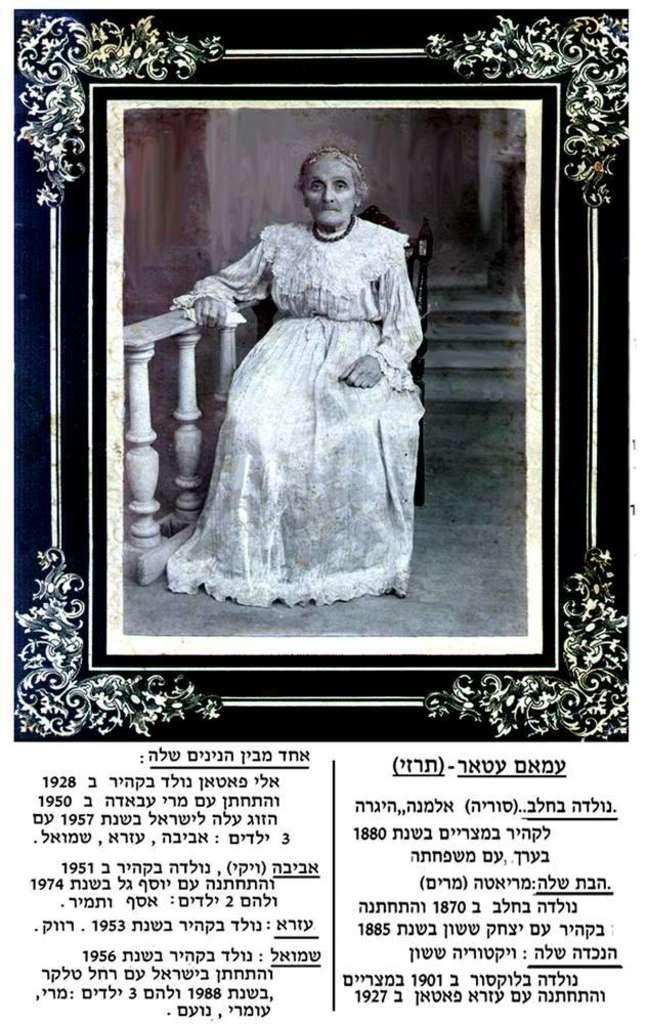What has been done to the image? The image has been edited. What else can be seen in the image besides the edited photo? There is text and a photo frame in the image. What is inside the photo frame? There is a woman in the photo frame. What is the woman doing in the photo frame? The woman is sitting and leaning on a railing. What color is the railing the woman is leaning on? The railing is white in color. What type of food is the woman eating in the image? There is no food present in the image, as the woman is in a photo frame and not actively eating. How comfortable is the woman in the image? The image does not provide information about the woman's comfort level, as it only shows her sitting and leaning on a railing. 